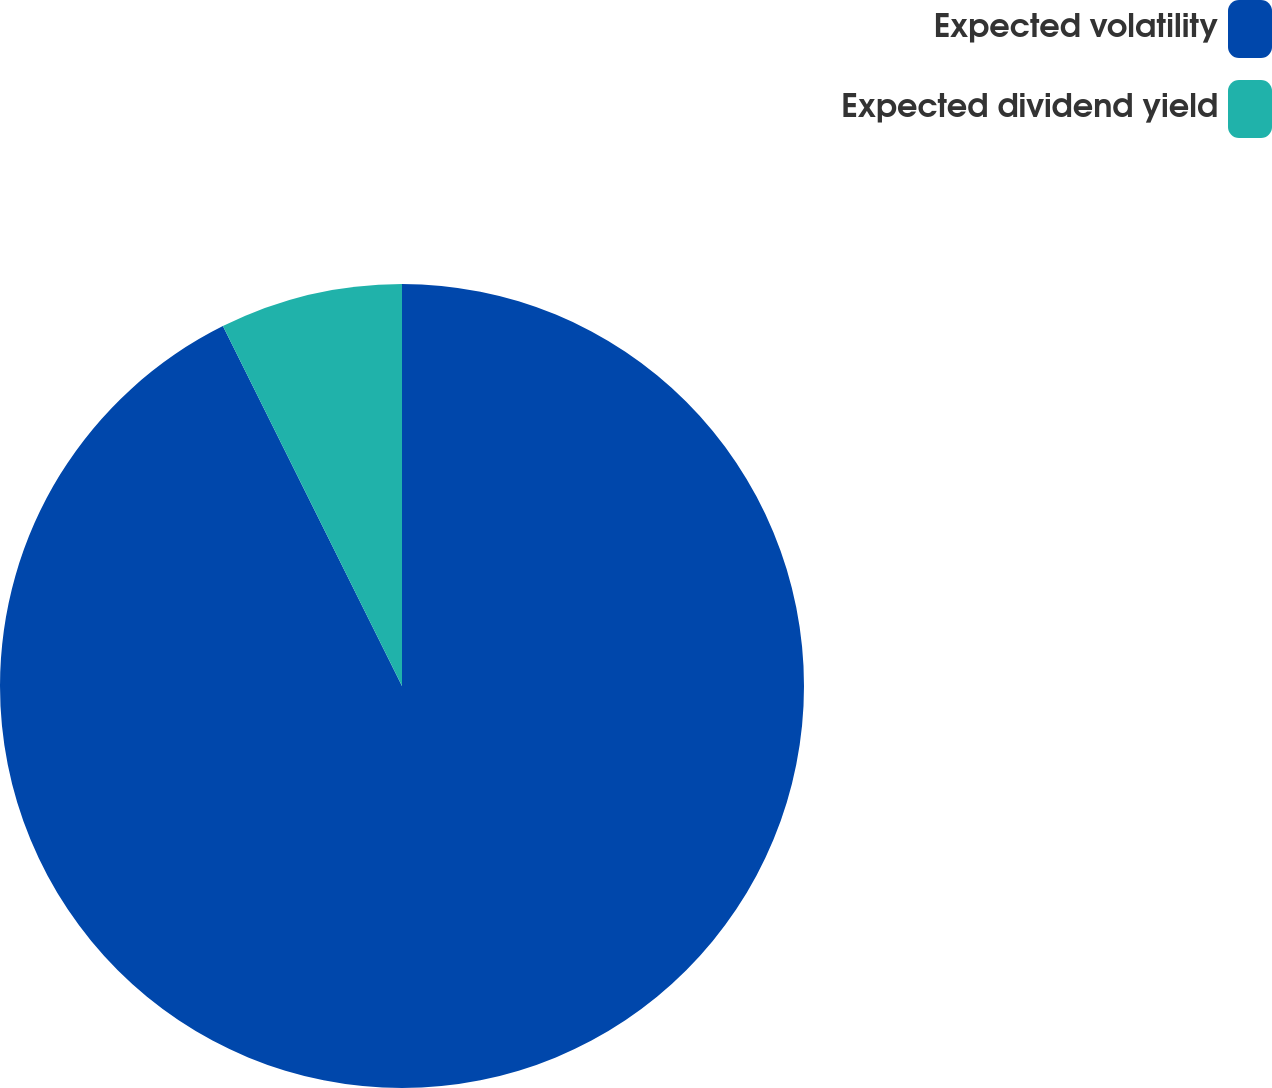Convert chart. <chart><loc_0><loc_0><loc_500><loc_500><pie_chart><fcel>Expected volatility<fcel>Expected dividend yield<nl><fcel>92.65%<fcel>7.35%<nl></chart> 